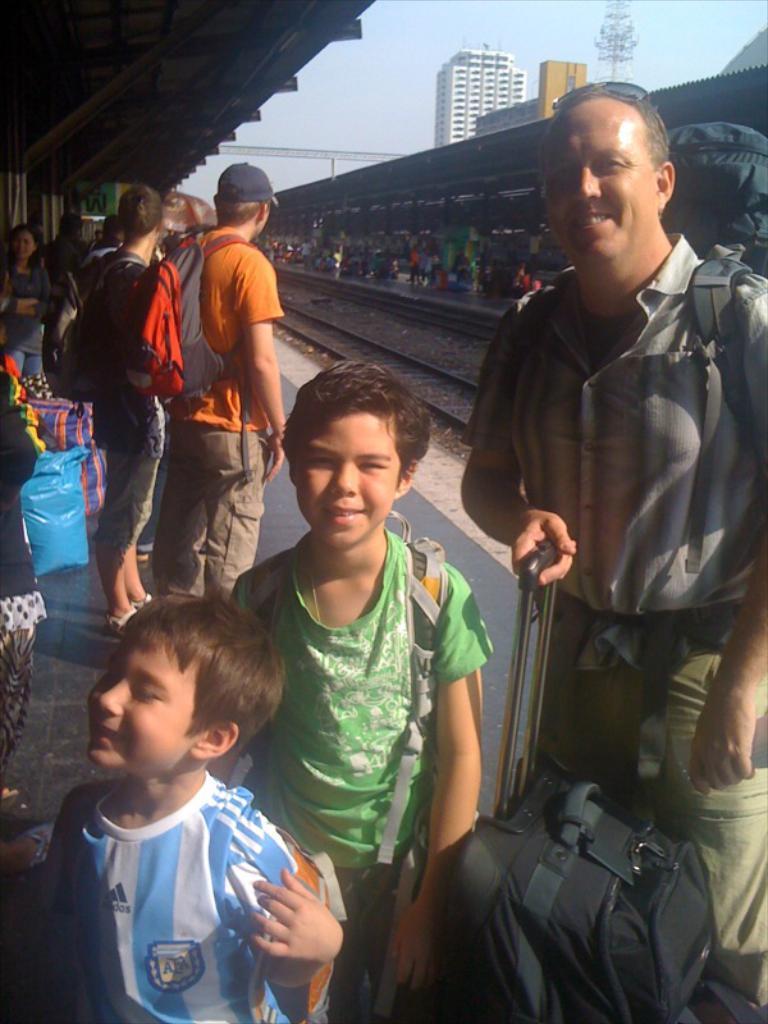Describe this image in one or two sentences. In this image we can see people standing in the platform. The man standing on the left is holding a briefcase. In the background there are railway tracks, buildings and sky. 